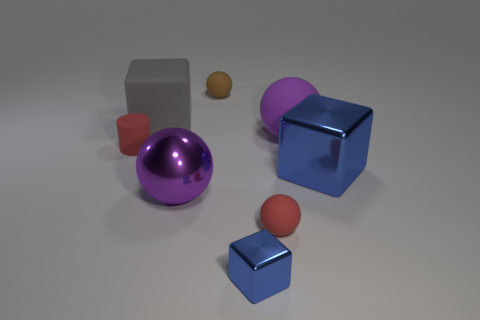What number of things are in front of the large gray rubber cube and behind the rubber cylinder?
Keep it short and to the point. 1. What material is the sphere that is the same size as the brown rubber object?
Your answer should be very brief. Rubber. There is a blue thing behind the small blue block; is it the same size as the brown ball that is behind the small metallic object?
Ensure brevity in your answer.  No. There is a tiny red matte cylinder; are there any metal blocks to the right of it?
Give a very brief answer. Yes. There is a big metal object that is on the right side of the large matte object that is to the right of the small metal block; what color is it?
Your response must be concise. Blue. Is the number of yellow matte objects less than the number of large metal cubes?
Make the answer very short. Yes. How many large blue things have the same shape as the brown thing?
Provide a short and direct response. 0. What color is the other block that is the same size as the gray cube?
Keep it short and to the point. Blue. Are there the same number of tiny matte objects in front of the large blue cube and tiny blocks to the right of the red cylinder?
Keep it short and to the point. Yes. Are there any brown matte balls of the same size as the matte cylinder?
Ensure brevity in your answer.  Yes. 